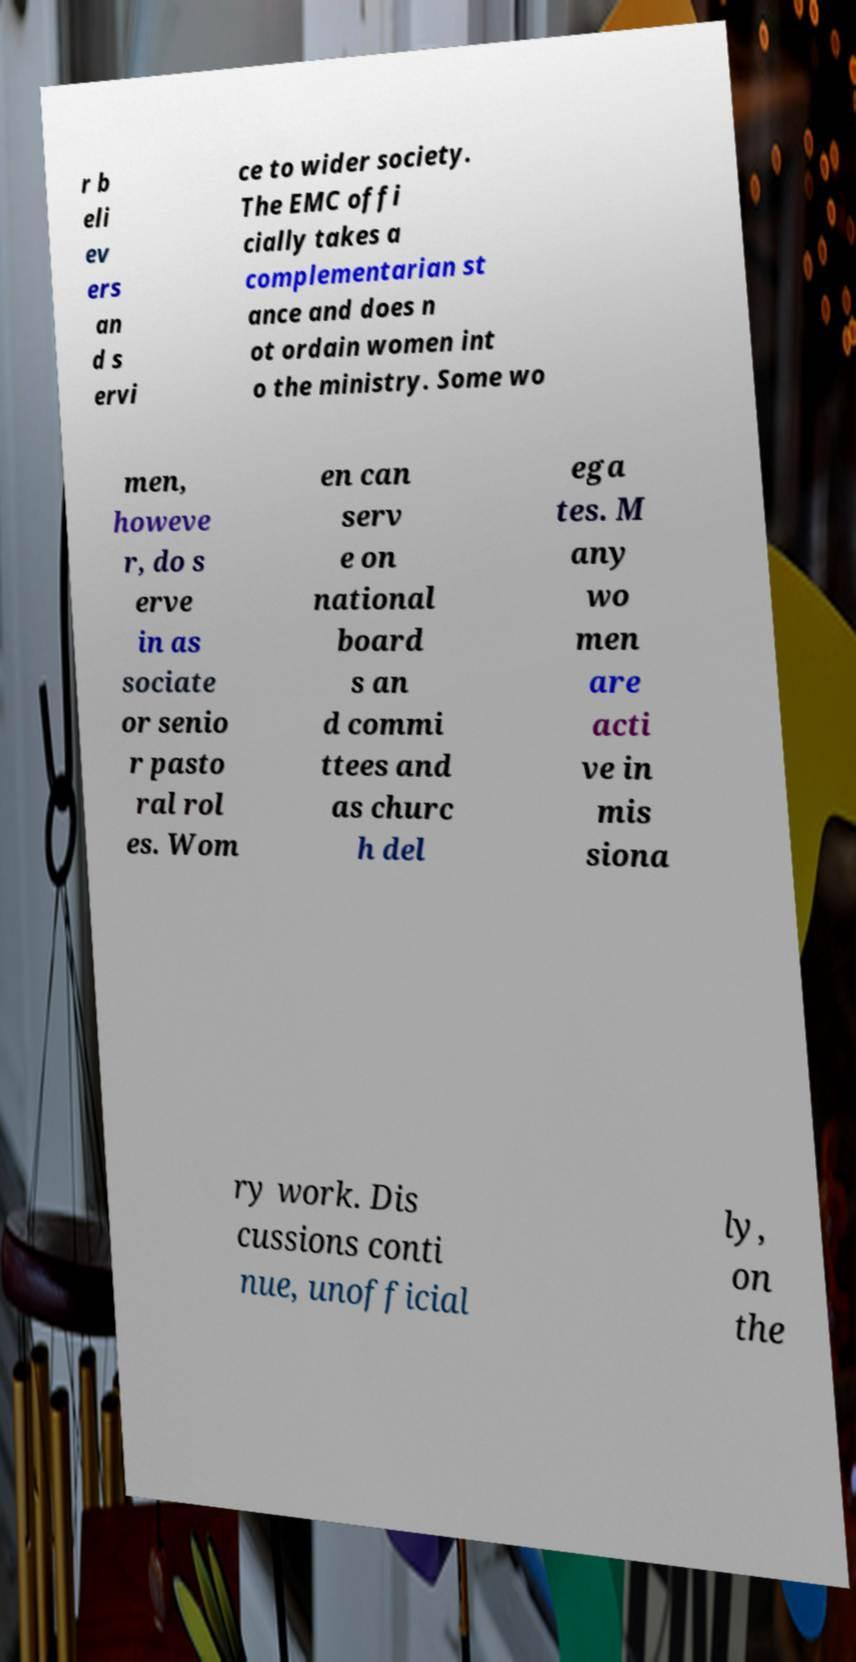There's text embedded in this image that I need extracted. Can you transcribe it verbatim? r b eli ev ers an d s ervi ce to wider society. The EMC offi cially takes a complementarian st ance and does n ot ordain women int o the ministry. Some wo men, howeve r, do s erve in as sociate or senio r pasto ral rol es. Wom en can serv e on national board s an d commi ttees and as churc h del ega tes. M any wo men are acti ve in mis siona ry work. Dis cussions conti nue, unofficial ly, on the 